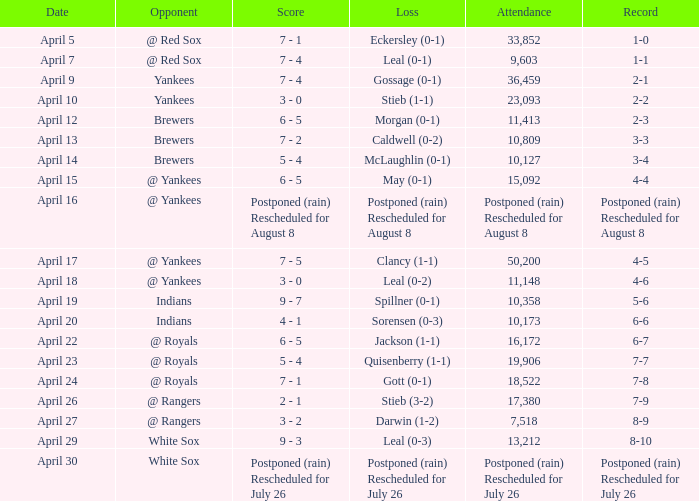What was the result of the game witnessed by 50,200? 7 - 5. 